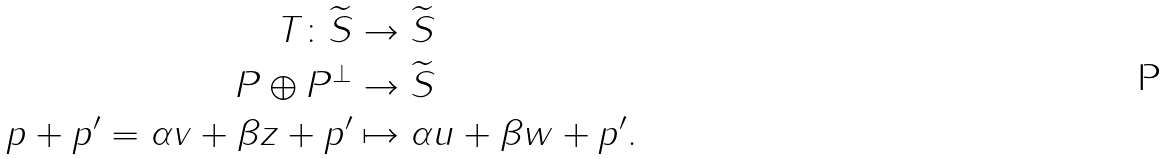Convert formula to latex. <formula><loc_0><loc_0><loc_500><loc_500>T \colon \widetilde { S } & \to \widetilde { S } \\ P \oplus P ^ { \bot } & \to \widetilde { S } \\ p + p ^ { \prime } = \alpha v + \beta z + p ^ { \prime } & \mapsto \alpha u + \beta w + p ^ { \prime } .</formula> 